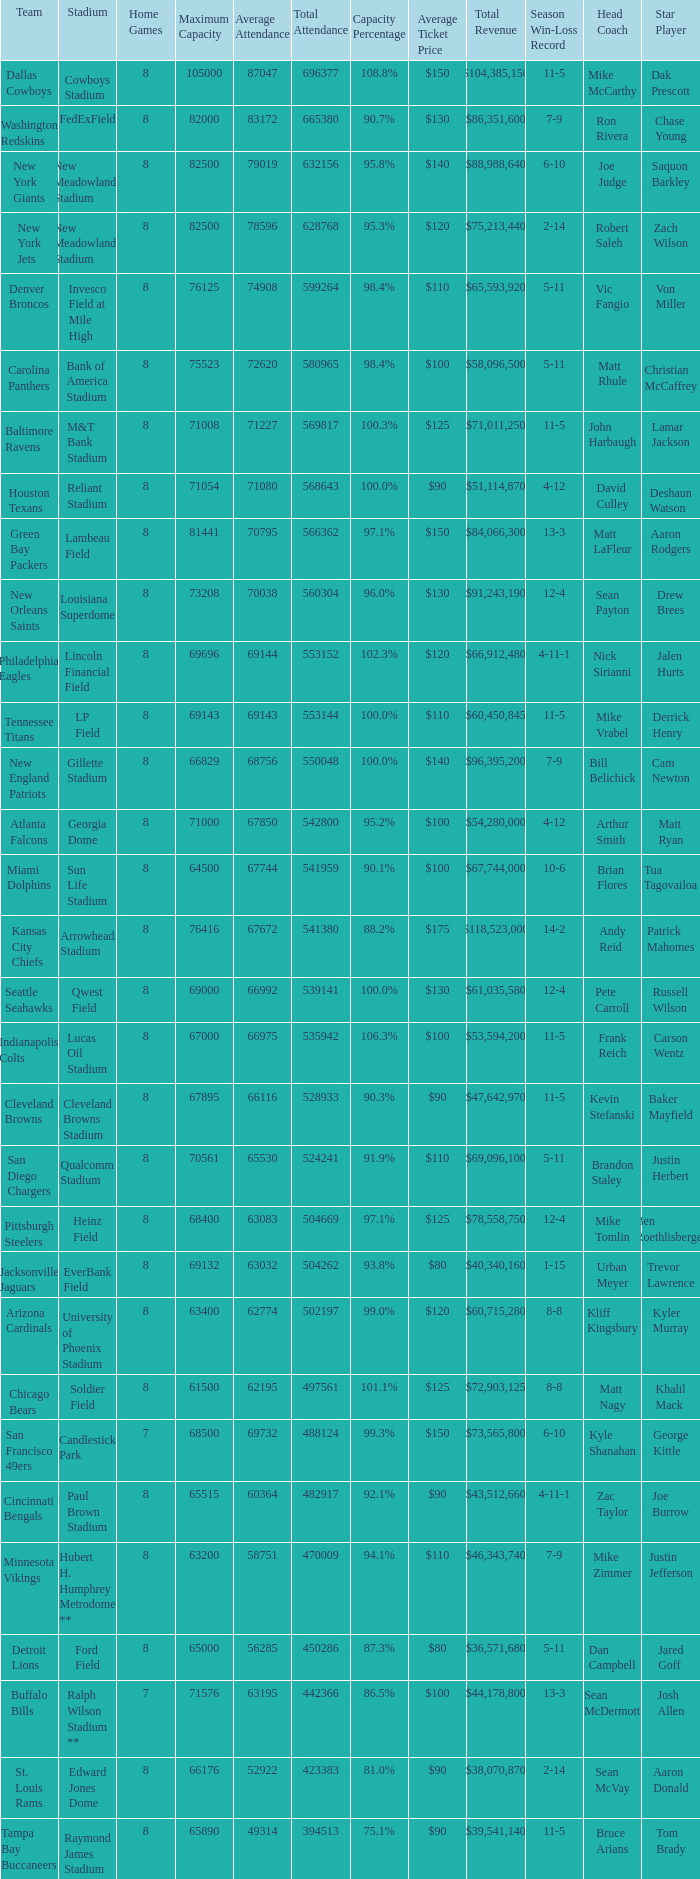What was the total attendance of the New York Giants? 632156.0. 